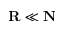Convert formula to latex. <formula><loc_0><loc_0><loc_500><loc_500>\mathbf R \ll \mathbf N</formula> 